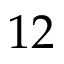Convert formula to latex. <formula><loc_0><loc_0><loc_500><loc_500>1 2</formula> 